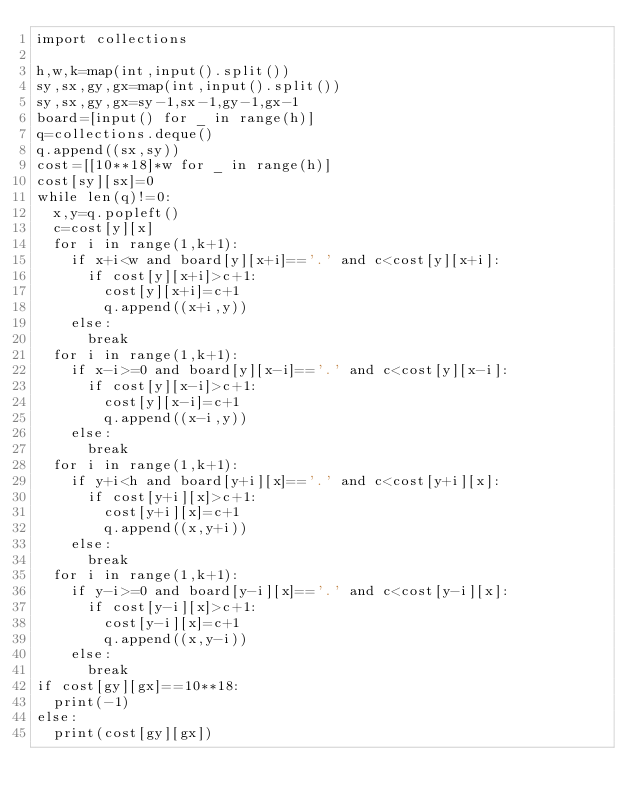Convert code to text. <code><loc_0><loc_0><loc_500><loc_500><_Python_>import collections

h,w,k=map(int,input().split())
sy,sx,gy,gx=map(int,input().split())
sy,sx,gy,gx=sy-1,sx-1,gy-1,gx-1
board=[input() for _ in range(h)]
q=collections.deque()
q.append((sx,sy))
cost=[[10**18]*w for _ in range(h)]
cost[sy][sx]=0
while len(q)!=0:
  x,y=q.popleft()
  c=cost[y][x]
  for i in range(1,k+1):
    if x+i<w and board[y][x+i]=='.' and c<cost[y][x+i]:
      if cost[y][x+i]>c+1:
        cost[y][x+i]=c+1
        q.append((x+i,y))
    else:
      break
  for i in range(1,k+1):
    if x-i>=0 and board[y][x-i]=='.' and c<cost[y][x-i]:
      if cost[y][x-i]>c+1:
        cost[y][x-i]=c+1
        q.append((x-i,y))
    else:
      break
  for i in range(1,k+1):
    if y+i<h and board[y+i][x]=='.' and c<cost[y+i][x]:
      if cost[y+i][x]>c+1:
        cost[y+i][x]=c+1
        q.append((x,y+i))
    else:
      break
  for i in range(1,k+1):
    if y-i>=0 and board[y-i][x]=='.' and c<cost[y-i][x]:
      if cost[y-i][x]>c+1:
        cost[y-i][x]=c+1
        q.append((x,y-i))
    else:
      break
if cost[gy][gx]==10**18:
  print(-1)
else:
  print(cost[gy][gx])</code> 